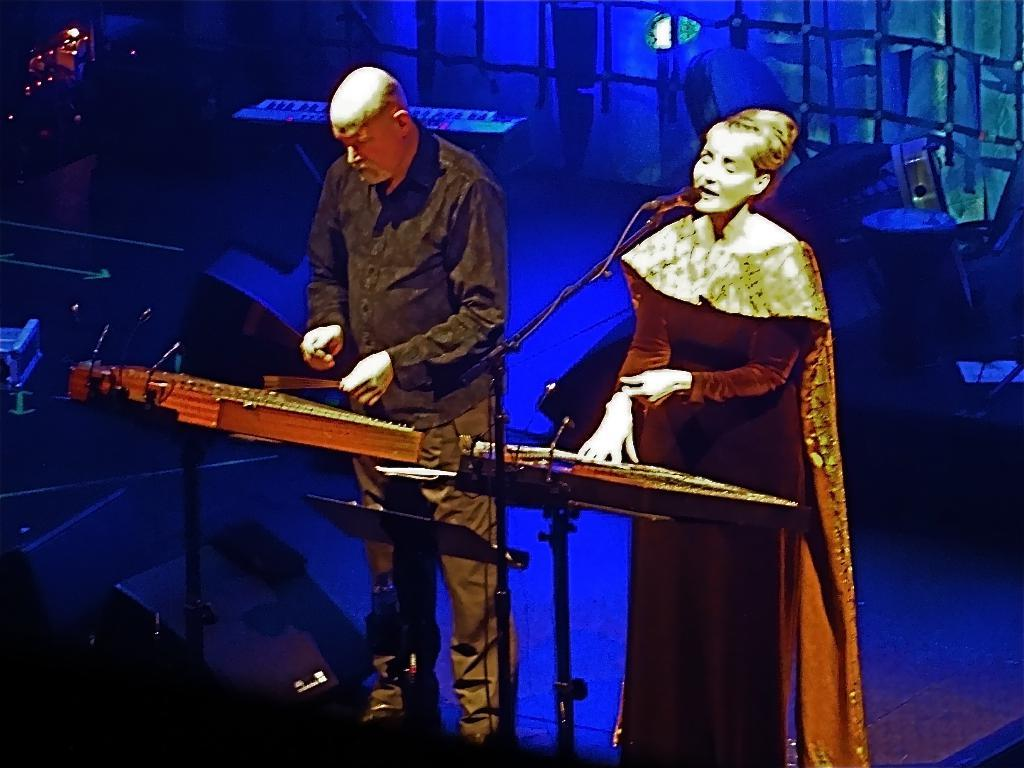How many people are present in the image? There are two people in the image, a woman and a man. What are the woman and the man doing in the image? Both the woman and the man are playing musical instruments. What is the woman doing specifically? The woman is singing with the help of a microphone. What else can be seen in the image related to music? There are additional musical instruments visible in the background. How many ladybugs are crawling on the tent in the image? There is no tent or ladybugs present in the image. 